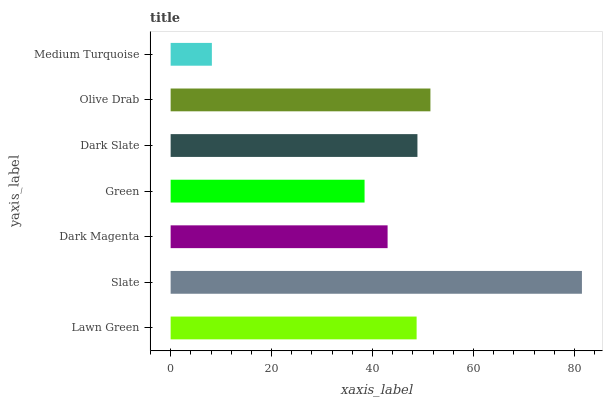Is Medium Turquoise the minimum?
Answer yes or no. Yes. Is Slate the maximum?
Answer yes or no. Yes. Is Dark Magenta the minimum?
Answer yes or no. No. Is Dark Magenta the maximum?
Answer yes or no. No. Is Slate greater than Dark Magenta?
Answer yes or no. Yes. Is Dark Magenta less than Slate?
Answer yes or no. Yes. Is Dark Magenta greater than Slate?
Answer yes or no. No. Is Slate less than Dark Magenta?
Answer yes or no. No. Is Lawn Green the high median?
Answer yes or no. Yes. Is Lawn Green the low median?
Answer yes or no. Yes. Is Medium Turquoise the high median?
Answer yes or no. No. Is Olive Drab the low median?
Answer yes or no. No. 